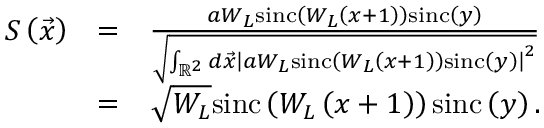Convert formula to latex. <formula><loc_0><loc_0><loc_500><loc_500>\begin{array} { r l r } { S \left ( \vec { x } \right ) } & { = } & { \frac { a W _ { L } \sin c \left ( W _ { L } \left ( x + 1 \right ) \right ) \sin c \left ( y \right ) } { \sqrt { \int _ { \mathbb { R } ^ { 2 } } d \vec { x } \left | a W _ { L } \sin c \left ( W _ { L } \left ( x + 1 \right ) \right ) \sin c \left ( y \right ) \right | ^ { 2 } } } } \\ & { = } & { \sqrt { W _ { L } } \sin c \left ( W _ { L } \left ( x + 1 \right ) \right ) \sin c \left ( y \right ) . } \end{array}</formula> 